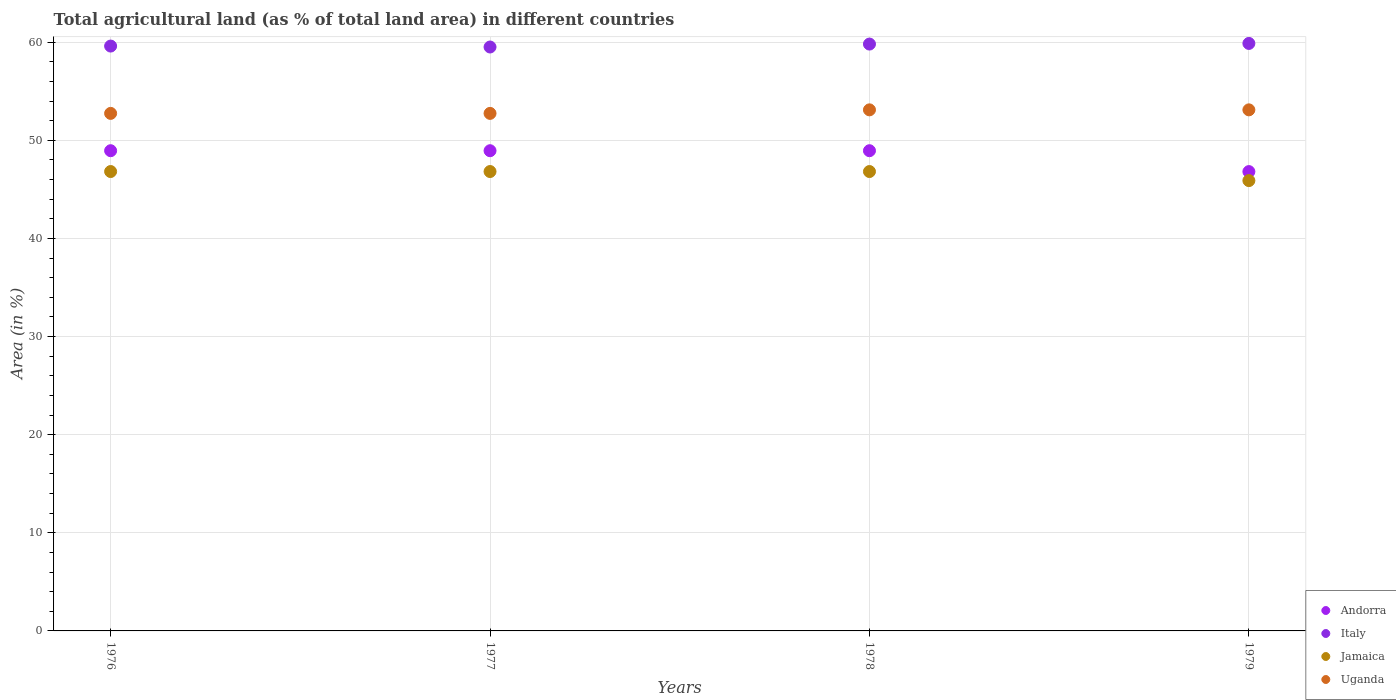How many different coloured dotlines are there?
Your response must be concise. 4. Is the number of dotlines equal to the number of legend labels?
Provide a short and direct response. Yes. What is the percentage of agricultural land in Italy in 1977?
Provide a succinct answer. 59.5. Across all years, what is the maximum percentage of agricultural land in Italy?
Make the answer very short. 59.87. Across all years, what is the minimum percentage of agricultural land in Jamaica?
Keep it short and to the point. 45.89. In which year was the percentage of agricultural land in Italy maximum?
Make the answer very short. 1979. In which year was the percentage of agricultural land in Uganda minimum?
Ensure brevity in your answer.  1976. What is the total percentage of agricultural land in Andorra in the graph?
Give a very brief answer. 193.62. What is the difference between the percentage of agricultural land in Uganda in 1977 and that in 1978?
Make the answer very short. -0.36. What is the difference between the percentage of agricultural land in Jamaica in 1979 and the percentage of agricultural land in Uganda in 1977?
Keep it short and to the point. -6.85. What is the average percentage of agricultural land in Uganda per year?
Give a very brief answer. 52.92. In the year 1978, what is the difference between the percentage of agricultural land in Italy and percentage of agricultural land in Andorra?
Offer a terse response. 10.87. In how many years, is the percentage of agricultural land in Italy greater than 40 %?
Keep it short and to the point. 4. What is the ratio of the percentage of agricultural land in Jamaica in 1977 to that in 1978?
Give a very brief answer. 1. What is the difference between the highest and the lowest percentage of agricultural land in Jamaica?
Provide a succinct answer. 0.92. In how many years, is the percentage of agricultural land in Jamaica greater than the average percentage of agricultural land in Jamaica taken over all years?
Provide a succinct answer. 3. Is the sum of the percentage of agricultural land in Uganda in 1977 and 1978 greater than the maximum percentage of agricultural land in Jamaica across all years?
Offer a very short reply. Yes. Is it the case that in every year, the sum of the percentage of agricultural land in Italy and percentage of agricultural land in Jamaica  is greater than the sum of percentage of agricultural land in Andorra and percentage of agricultural land in Uganda?
Ensure brevity in your answer.  Yes. Does the percentage of agricultural land in Uganda monotonically increase over the years?
Your response must be concise. No. Is the percentage of agricultural land in Andorra strictly greater than the percentage of agricultural land in Jamaica over the years?
Provide a short and direct response. Yes. Is the percentage of agricultural land in Jamaica strictly less than the percentage of agricultural land in Uganda over the years?
Your answer should be compact. Yes. How many years are there in the graph?
Keep it short and to the point. 4. What is the difference between two consecutive major ticks on the Y-axis?
Provide a short and direct response. 10. Where does the legend appear in the graph?
Make the answer very short. Bottom right. How many legend labels are there?
Give a very brief answer. 4. How are the legend labels stacked?
Make the answer very short. Vertical. What is the title of the graph?
Provide a succinct answer. Total agricultural land (as % of total land area) in different countries. Does "Antigua and Barbuda" appear as one of the legend labels in the graph?
Offer a terse response. No. What is the label or title of the X-axis?
Offer a very short reply. Years. What is the label or title of the Y-axis?
Provide a short and direct response. Area (in %). What is the Area (in %) in Andorra in 1976?
Your response must be concise. 48.94. What is the Area (in %) in Italy in 1976?
Make the answer very short. 59.6. What is the Area (in %) of Jamaica in 1976?
Give a very brief answer. 46.81. What is the Area (in %) of Uganda in 1976?
Give a very brief answer. 52.74. What is the Area (in %) in Andorra in 1977?
Offer a very short reply. 48.94. What is the Area (in %) in Italy in 1977?
Your answer should be compact. 59.5. What is the Area (in %) in Jamaica in 1977?
Provide a short and direct response. 46.81. What is the Area (in %) of Uganda in 1977?
Give a very brief answer. 52.74. What is the Area (in %) of Andorra in 1978?
Your answer should be compact. 48.94. What is the Area (in %) in Italy in 1978?
Provide a succinct answer. 59.8. What is the Area (in %) of Jamaica in 1978?
Make the answer very short. 46.81. What is the Area (in %) in Uganda in 1978?
Offer a very short reply. 53.1. What is the Area (in %) of Andorra in 1979?
Ensure brevity in your answer.  46.81. What is the Area (in %) in Italy in 1979?
Keep it short and to the point. 59.87. What is the Area (in %) in Jamaica in 1979?
Your answer should be very brief. 45.89. What is the Area (in %) of Uganda in 1979?
Provide a succinct answer. 53.1. Across all years, what is the maximum Area (in %) in Andorra?
Give a very brief answer. 48.94. Across all years, what is the maximum Area (in %) in Italy?
Provide a short and direct response. 59.87. Across all years, what is the maximum Area (in %) in Jamaica?
Give a very brief answer. 46.81. Across all years, what is the maximum Area (in %) in Uganda?
Give a very brief answer. 53.1. Across all years, what is the minimum Area (in %) in Andorra?
Ensure brevity in your answer.  46.81. Across all years, what is the minimum Area (in %) in Italy?
Your response must be concise. 59.5. Across all years, what is the minimum Area (in %) in Jamaica?
Make the answer very short. 45.89. Across all years, what is the minimum Area (in %) of Uganda?
Offer a very short reply. 52.74. What is the total Area (in %) in Andorra in the graph?
Make the answer very short. 193.62. What is the total Area (in %) in Italy in the graph?
Offer a very short reply. 238.78. What is the total Area (in %) in Jamaica in the graph?
Keep it short and to the point. 186.33. What is the total Area (in %) of Uganda in the graph?
Your response must be concise. 211.68. What is the difference between the Area (in %) of Italy in 1976 and that in 1977?
Your answer should be compact. 0.1. What is the difference between the Area (in %) in Jamaica in 1976 and that in 1977?
Your response must be concise. 0. What is the difference between the Area (in %) in Italy in 1976 and that in 1978?
Give a very brief answer. -0.2. What is the difference between the Area (in %) of Jamaica in 1976 and that in 1978?
Your answer should be compact. 0. What is the difference between the Area (in %) of Uganda in 1976 and that in 1978?
Make the answer very short. -0.36. What is the difference between the Area (in %) in Andorra in 1976 and that in 1979?
Offer a very short reply. 2.13. What is the difference between the Area (in %) of Italy in 1976 and that in 1979?
Keep it short and to the point. -0.27. What is the difference between the Area (in %) in Jamaica in 1976 and that in 1979?
Make the answer very short. 0.92. What is the difference between the Area (in %) in Uganda in 1976 and that in 1979?
Your answer should be compact. -0.36. What is the difference between the Area (in %) in Italy in 1977 and that in 1978?
Make the answer very short. -0.3. What is the difference between the Area (in %) of Uganda in 1977 and that in 1978?
Offer a terse response. -0.36. What is the difference between the Area (in %) of Andorra in 1977 and that in 1979?
Provide a short and direct response. 2.13. What is the difference between the Area (in %) of Italy in 1977 and that in 1979?
Offer a very short reply. -0.36. What is the difference between the Area (in %) of Jamaica in 1977 and that in 1979?
Your answer should be compact. 0.92. What is the difference between the Area (in %) in Uganda in 1977 and that in 1979?
Keep it short and to the point. -0.36. What is the difference between the Area (in %) of Andorra in 1978 and that in 1979?
Make the answer very short. 2.13. What is the difference between the Area (in %) of Italy in 1978 and that in 1979?
Keep it short and to the point. -0.06. What is the difference between the Area (in %) of Jamaica in 1978 and that in 1979?
Your answer should be very brief. 0.92. What is the difference between the Area (in %) in Uganda in 1978 and that in 1979?
Keep it short and to the point. 0. What is the difference between the Area (in %) in Andorra in 1976 and the Area (in %) in Italy in 1977?
Ensure brevity in your answer.  -10.57. What is the difference between the Area (in %) of Andorra in 1976 and the Area (in %) of Jamaica in 1977?
Make the answer very short. 2.12. What is the difference between the Area (in %) in Andorra in 1976 and the Area (in %) in Uganda in 1977?
Offer a very short reply. -3.8. What is the difference between the Area (in %) of Italy in 1976 and the Area (in %) of Jamaica in 1977?
Provide a succinct answer. 12.79. What is the difference between the Area (in %) in Italy in 1976 and the Area (in %) in Uganda in 1977?
Give a very brief answer. 6.86. What is the difference between the Area (in %) in Jamaica in 1976 and the Area (in %) in Uganda in 1977?
Give a very brief answer. -5.93. What is the difference between the Area (in %) in Andorra in 1976 and the Area (in %) in Italy in 1978?
Offer a very short reply. -10.87. What is the difference between the Area (in %) of Andorra in 1976 and the Area (in %) of Jamaica in 1978?
Your response must be concise. 2.12. What is the difference between the Area (in %) in Andorra in 1976 and the Area (in %) in Uganda in 1978?
Ensure brevity in your answer.  -4.16. What is the difference between the Area (in %) of Italy in 1976 and the Area (in %) of Jamaica in 1978?
Your answer should be very brief. 12.79. What is the difference between the Area (in %) in Italy in 1976 and the Area (in %) in Uganda in 1978?
Your answer should be compact. 6.5. What is the difference between the Area (in %) of Jamaica in 1976 and the Area (in %) of Uganda in 1978?
Provide a succinct answer. -6.29. What is the difference between the Area (in %) of Andorra in 1976 and the Area (in %) of Italy in 1979?
Provide a short and direct response. -10.93. What is the difference between the Area (in %) of Andorra in 1976 and the Area (in %) of Jamaica in 1979?
Ensure brevity in your answer.  3.05. What is the difference between the Area (in %) of Andorra in 1976 and the Area (in %) of Uganda in 1979?
Ensure brevity in your answer.  -4.16. What is the difference between the Area (in %) of Italy in 1976 and the Area (in %) of Jamaica in 1979?
Your answer should be compact. 13.71. What is the difference between the Area (in %) in Italy in 1976 and the Area (in %) in Uganda in 1979?
Your answer should be compact. 6.5. What is the difference between the Area (in %) of Jamaica in 1976 and the Area (in %) of Uganda in 1979?
Make the answer very short. -6.29. What is the difference between the Area (in %) in Andorra in 1977 and the Area (in %) in Italy in 1978?
Ensure brevity in your answer.  -10.87. What is the difference between the Area (in %) of Andorra in 1977 and the Area (in %) of Jamaica in 1978?
Offer a terse response. 2.12. What is the difference between the Area (in %) in Andorra in 1977 and the Area (in %) in Uganda in 1978?
Your answer should be very brief. -4.16. What is the difference between the Area (in %) of Italy in 1977 and the Area (in %) of Jamaica in 1978?
Your response must be concise. 12.69. What is the difference between the Area (in %) in Italy in 1977 and the Area (in %) in Uganda in 1978?
Ensure brevity in your answer.  6.4. What is the difference between the Area (in %) in Jamaica in 1977 and the Area (in %) in Uganda in 1978?
Your answer should be very brief. -6.29. What is the difference between the Area (in %) of Andorra in 1977 and the Area (in %) of Italy in 1979?
Offer a terse response. -10.93. What is the difference between the Area (in %) of Andorra in 1977 and the Area (in %) of Jamaica in 1979?
Keep it short and to the point. 3.05. What is the difference between the Area (in %) of Andorra in 1977 and the Area (in %) of Uganda in 1979?
Your answer should be very brief. -4.16. What is the difference between the Area (in %) of Italy in 1977 and the Area (in %) of Jamaica in 1979?
Provide a succinct answer. 13.61. What is the difference between the Area (in %) of Italy in 1977 and the Area (in %) of Uganda in 1979?
Offer a terse response. 6.4. What is the difference between the Area (in %) of Jamaica in 1977 and the Area (in %) of Uganda in 1979?
Keep it short and to the point. -6.29. What is the difference between the Area (in %) in Andorra in 1978 and the Area (in %) in Italy in 1979?
Provide a short and direct response. -10.93. What is the difference between the Area (in %) in Andorra in 1978 and the Area (in %) in Jamaica in 1979?
Your response must be concise. 3.05. What is the difference between the Area (in %) in Andorra in 1978 and the Area (in %) in Uganda in 1979?
Keep it short and to the point. -4.16. What is the difference between the Area (in %) of Italy in 1978 and the Area (in %) of Jamaica in 1979?
Offer a terse response. 13.91. What is the difference between the Area (in %) of Italy in 1978 and the Area (in %) of Uganda in 1979?
Your answer should be compact. 6.7. What is the difference between the Area (in %) in Jamaica in 1978 and the Area (in %) in Uganda in 1979?
Your response must be concise. -6.29. What is the average Area (in %) in Andorra per year?
Provide a short and direct response. 48.4. What is the average Area (in %) in Italy per year?
Offer a terse response. 59.69. What is the average Area (in %) in Jamaica per year?
Keep it short and to the point. 46.58. What is the average Area (in %) in Uganda per year?
Keep it short and to the point. 52.92. In the year 1976, what is the difference between the Area (in %) in Andorra and Area (in %) in Italy?
Your response must be concise. -10.66. In the year 1976, what is the difference between the Area (in %) in Andorra and Area (in %) in Jamaica?
Your answer should be compact. 2.12. In the year 1976, what is the difference between the Area (in %) in Andorra and Area (in %) in Uganda?
Your answer should be very brief. -3.8. In the year 1976, what is the difference between the Area (in %) in Italy and Area (in %) in Jamaica?
Offer a terse response. 12.79. In the year 1976, what is the difference between the Area (in %) of Italy and Area (in %) of Uganda?
Your answer should be compact. 6.86. In the year 1976, what is the difference between the Area (in %) in Jamaica and Area (in %) in Uganda?
Provide a succinct answer. -5.93. In the year 1977, what is the difference between the Area (in %) of Andorra and Area (in %) of Italy?
Make the answer very short. -10.57. In the year 1977, what is the difference between the Area (in %) of Andorra and Area (in %) of Jamaica?
Provide a short and direct response. 2.12. In the year 1977, what is the difference between the Area (in %) in Andorra and Area (in %) in Uganda?
Give a very brief answer. -3.8. In the year 1977, what is the difference between the Area (in %) of Italy and Area (in %) of Jamaica?
Give a very brief answer. 12.69. In the year 1977, what is the difference between the Area (in %) of Italy and Area (in %) of Uganda?
Your response must be concise. 6.76. In the year 1977, what is the difference between the Area (in %) of Jamaica and Area (in %) of Uganda?
Make the answer very short. -5.93. In the year 1978, what is the difference between the Area (in %) in Andorra and Area (in %) in Italy?
Offer a very short reply. -10.87. In the year 1978, what is the difference between the Area (in %) in Andorra and Area (in %) in Jamaica?
Your response must be concise. 2.12. In the year 1978, what is the difference between the Area (in %) of Andorra and Area (in %) of Uganda?
Your answer should be very brief. -4.16. In the year 1978, what is the difference between the Area (in %) in Italy and Area (in %) in Jamaica?
Your answer should be very brief. 12.99. In the year 1978, what is the difference between the Area (in %) in Italy and Area (in %) in Uganda?
Keep it short and to the point. 6.7. In the year 1978, what is the difference between the Area (in %) of Jamaica and Area (in %) of Uganda?
Your answer should be compact. -6.29. In the year 1979, what is the difference between the Area (in %) of Andorra and Area (in %) of Italy?
Ensure brevity in your answer.  -13.06. In the year 1979, what is the difference between the Area (in %) in Andorra and Area (in %) in Jamaica?
Make the answer very short. 0.92. In the year 1979, what is the difference between the Area (in %) in Andorra and Area (in %) in Uganda?
Offer a terse response. -6.29. In the year 1979, what is the difference between the Area (in %) in Italy and Area (in %) in Jamaica?
Your response must be concise. 13.98. In the year 1979, what is the difference between the Area (in %) of Italy and Area (in %) of Uganda?
Offer a very short reply. 6.77. In the year 1979, what is the difference between the Area (in %) in Jamaica and Area (in %) in Uganda?
Your answer should be compact. -7.21. What is the ratio of the Area (in %) in Andorra in 1976 to that in 1977?
Your answer should be compact. 1. What is the ratio of the Area (in %) in Italy in 1976 to that in 1977?
Keep it short and to the point. 1. What is the ratio of the Area (in %) in Jamaica in 1976 to that in 1977?
Provide a succinct answer. 1. What is the ratio of the Area (in %) in Uganda in 1976 to that in 1977?
Ensure brevity in your answer.  1. What is the ratio of the Area (in %) in Jamaica in 1976 to that in 1978?
Provide a succinct answer. 1. What is the ratio of the Area (in %) in Uganda in 1976 to that in 1978?
Provide a succinct answer. 0.99. What is the ratio of the Area (in %) of Andorra in 1976 to that in 1979?
Give a very brief answer. 1.05. What is the ratio of the Area (in %) in Jamaica in 1976 to that in 1979?
Your response must be concise. 1.02. What is the ratio of the Area (in %) of Uganda in 1976 to that in 1979?
Your answer should be compact. 0.99. What is the ratio of the Area (in %) in Jamaica in 1977 to that in 1978?
Your answer should be compact. 1. What is the ratio of the Area (in %) in Uganda in 1977 to that in 1978?
Your answer should be very brief. 0.99. What is the ratio of the Area (in %) of Andorra in 1977 to that in 1979?
Give a very brief answer. 1.05. What is the ratio of the Area (in %) in Italy in 1977 to that in 1979?
Give a very brief answer. 0.99. What is the ratio of the Area (in %) in Jamaica in 1977 to that in 1979?
Your answer should be very brief. 1.02. What is the ratio of the Area (in %) of Andorra in 1978 to that in 1979?
Your answer should be very brief. 1.05. What is the ratio of the Area (in %) of Italy in 1978 to that in 1979?
Your answer should be very brief. 1. What is the ratio of the Area (in %) of Jamaica in 1978 to that in 1979?
Your answer should be very brief. 1.02. What is the ratio of the Area (in %) in Uganda in 1978 to that in 1979?
Make the answer very short. 1. What is the difference between the highest and the second highest Area (in %) in Andorra?
Your answer should be very brief. 0. What is the difference between the highest and the second highest Area (in %) in Italy?
Your response must be concise. 0.06. What is the difference between the highest and the second highest Area (in %) of Jamaica?
Provide a short and direct response. 0. What is the difference between the highest and the lowest Area (in %) of Andorra?
Give a very brief answer. 2.13. What is the difference between the highest and the lowest Area (in %) of Italy?
Provide a succinct answer. 0.36. What is the difference between the highest and the lowest Area (in %) of Jamaica?
Your answer should be very brief. 0.92. What is the difference between the highest and the lowest Area (in %) of Uganda?
Your answer should be compact. 0.36. 